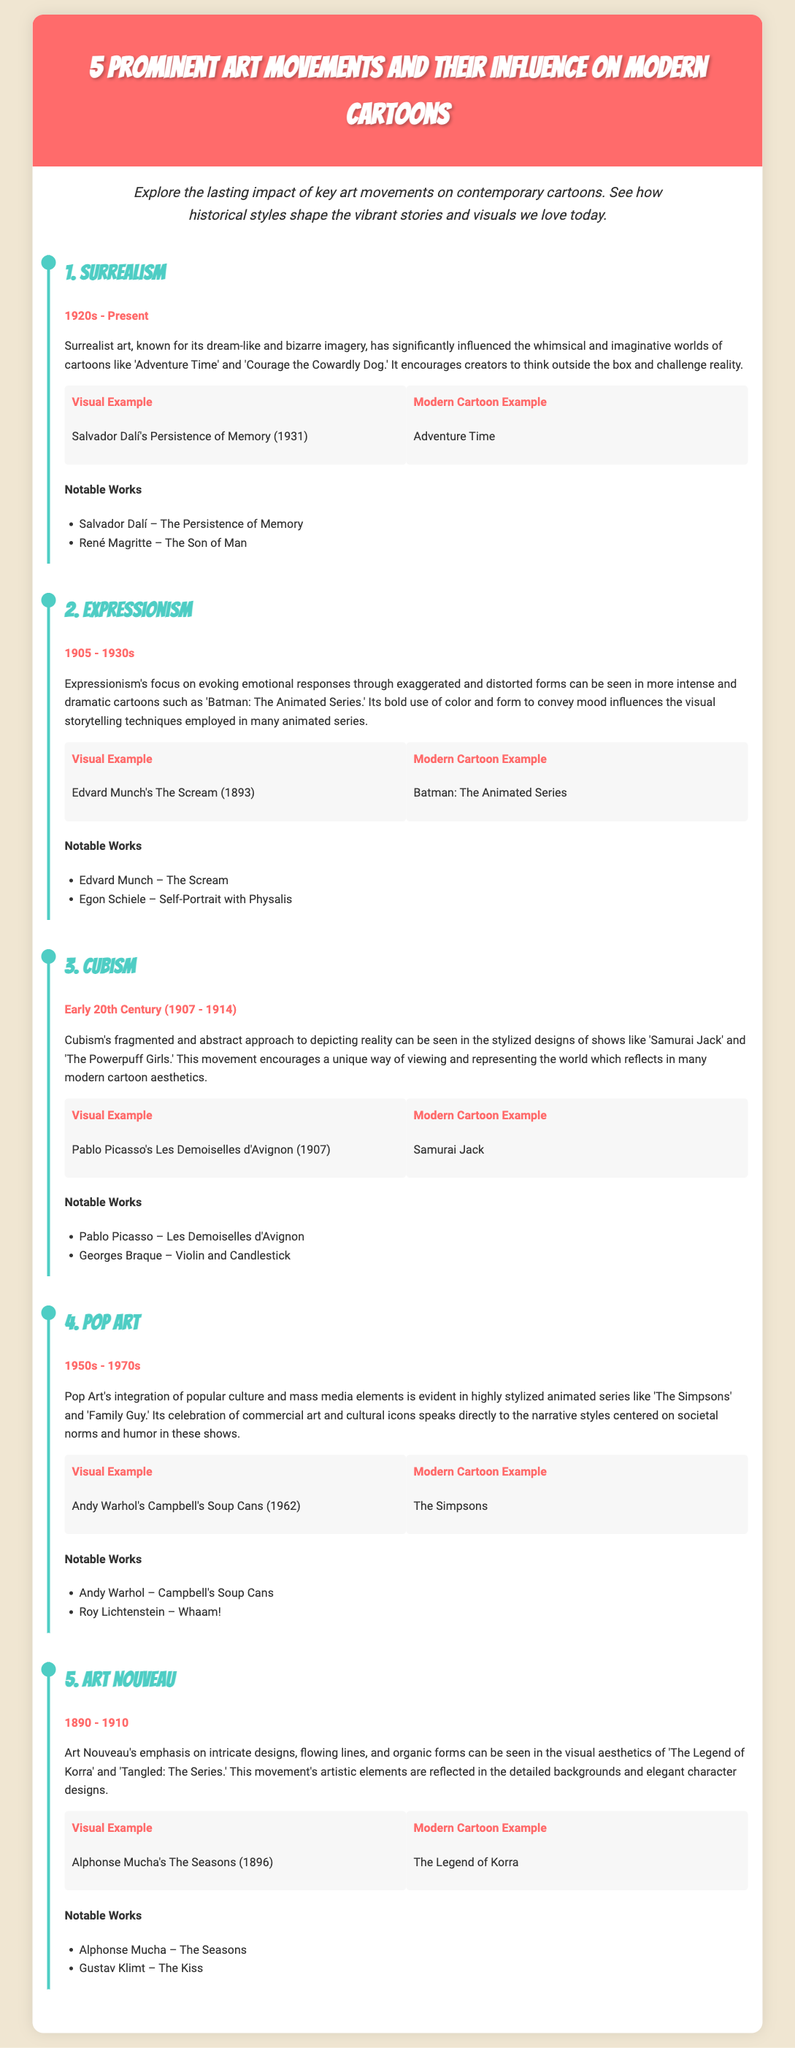What art movement does 'Adventure Time' influence originate from? 'Adventure Time' is influenced by Surrealism, which is known for its dream-like and bizarre imagery.
Answer: Surrealism What is the timeline period for Expressionism? The timeline for Expressionism is from 1905 to the 1930s, as indicated in the document.
Answer: 1905 - 1930s Who is a notable artist associated with Cubism? A notable artist associated with Cubism mentioned in the document is Pablo Picasso.
Answer: Pablo Picasso Which modern cartoon is influenced by Pop Art? The modern cartoon influenced by Pop Art is 'The Simpsons,' which incorporates popular culture and mass media elements.
Answer: The Simpsons What is the visual example from the Art Nouveau movement? The visual example from the Art Nouveau movement is Alphonse Mucha's 'The Seasons' (1896).
Answer: The Seasons How does Expressionism influence modern cartoons? Expressionism influences modern cartoons through its focus on evoking emotional responses using exaggerated and distorted forms.
Answer: Evoking emotional responses What are the notable works mentioned for Surrealism? The notable works mentioned for Surrealism are 'The Persistence of Memory' and 'The Son of Man.'
Answer: The Persistence of Memory, The Son of Man Which cartoon example is cited for its influence from Art Nouveau? 'The Legend of Korra' is cited as a modern cartoon example that reflects the influence of Art Nouveau.
Answer: The Legend of Korra What characterizes the influence of Cubism on modern cartoons? The influence of Cubism on modern cartoons is characterized by fragmented and abstract approaches to depicting reality.
Answer: Fragmented and abstract approaches 